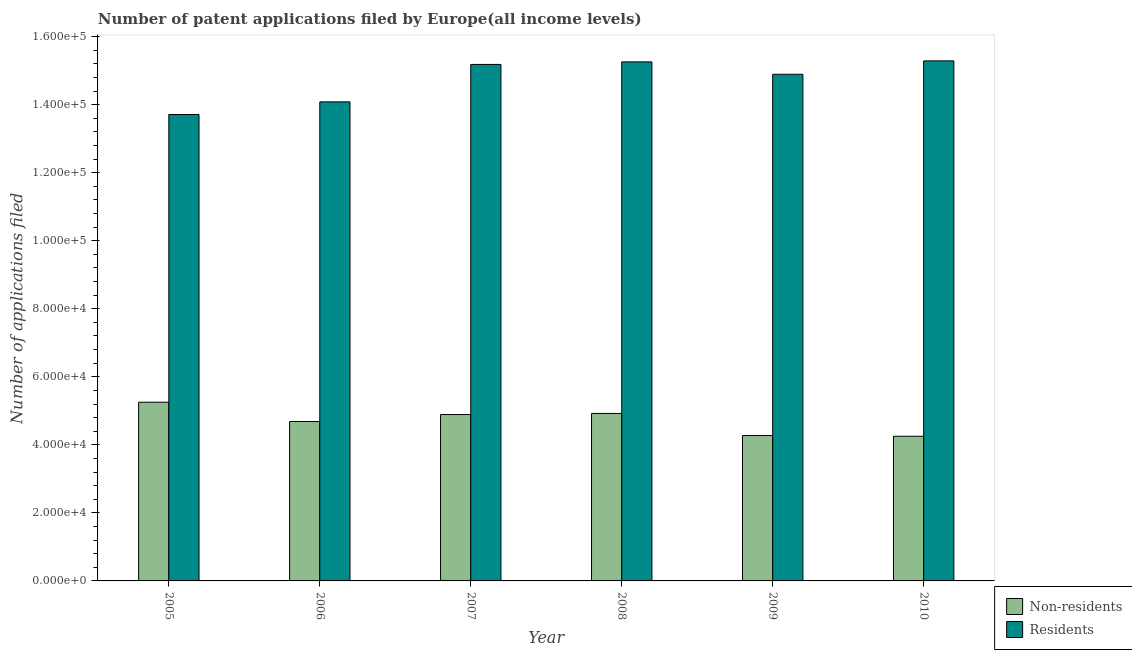How many different coloured bars are there?
Your response must be concise. 2. How many bars are there on the 3rd tick from the right?
Offer a very short reply. 2. What is the number of patent applications by residents in 2008?
Offer a very short reply. 1.53e+05. Across all years, what is the maximum number of patent applications by residents?
Provide a succinct answer. 1.53e+05. Across all years, what is the minimum number of patent applications by non residents?
Make the answer very short. 4.25e+04. In which year was the number of patent applications by non residents maximum?
Provide a short and direct response. 2005. In which year was the number of patent applications by residents minimum?
Your answer should be compact. 2005. What is the total number of patent applications by non residents in the graph?
Ensure brevity in your answer.  2.83e+05. What is the difference between the number of patent applications by residents in 2006 and that in 2009?
Your response must be concise. -8110. What is the difference between the number of patent applications by residents in 2006 and the number of patent applications by non residents in 2009?
Your answer should be very brief. -8110. What is the average number of patent applications by non residents per year?
Provide a succinct answer. 4.71e+04. In how many years, is the number of patent applications by non residents greater than 116000?
Offer a terse response. 0. What is the ratio of the number of patent applications by non residents in 2006 to that in 2007?
Provide a short and direct response. 0.96. Is the difference between the number of patent applications by residents in 2007 and 2008 greater than the difference between the number of patent applications by non residents in 2007 and 2008?
Provide a succinct answer. No. What is the difference between the highest and the second highest number of patent applications by non residents?
Provide a short and direct response. 3296. What is the difference between the highest and the lowest number of patent applications by residents?
Provide a short and direct response. 1.58e+04. In how many years, is the number of patent applications by residents greater than the average number of patent applications by residents taken over all years?
Offer a terse response. 4. Is the sum of the number of patent applications by residents in 2007 and 2009 greater than the maximum number of patent applications by non residents across all years?
Keep it short and to the point. Yes. What does the 2nd bar from the left in 2006 represents?
Your answer should be compact. Residents. What does the 1st bar from the right in 2009 represents?
Ensure brevity in your answer.  Residents. How many years are there in the graph?
Provide a succinct answer. 6. What is the difference between two consecutive major ticks on the Y-axis?
Your response must be concise. 2.00e+04. Are the values on the major ticks of Y-axis written in scientific E-notation?
Provide a succinct answer. Yes. Does the graph contain any zero values?
Your answer should be very brief. No. How are the legend labels stacked?
Your response must be concise. Vertical. What is the title of the graph?
Your answer should be very brief. Number of patent applications filed by Europe(all income levels). What is the label or title of the X-axis?
Make the answer very short. Year. What is the label or title of the Y-axis?
Offer a very short reply. Number of applications filed. What is the Number of applications filed in Non-residents in 2005?
Ensure brevity in your answer.  5.25e+04. What is the Number of applications filed in Residents in 2005?
Keep it short and to the point. 1.37e+05. What is the Number of applications filed of Non-residents in 2006?
Provide a succinct answer. 4.69e+04. What is the Number of applications filed of Residents in 2006?
Offer a very short reply. 1.41e+05. What is the Number of applications filed in Non-residents in 2007?
Your response must be concise. 4.89e+04. What is the Number of applications filed in Residents in 2007?
Provide a short and direct response. 1.52e+05. What is the Number of applications filed in Non-residents in 2008?
Your answer should be very brief. 4.92e+04. What is the Number of applications filed of Residents in 2008?
Provide a succinct answer. 1.53e+05. What is the Number of applications filed of Non-residents in 2009?
Offer a terse response. 4.27e+04. What is the Number of applications filed of Residents in 2009?
Ensure brevity in your answer.  1.49e+05. What is the Number of applications filed of Non-residents in 2010?
Offer a terse response. 4.25e+04. What is the Number of applications filed in Residents in 2010?
Make the answer very short. 1.53e+05. Across all years, what is the maximum Number of applications filed in Non-residents?
Your response must be concise. 5.25e+04. Across all years, what is the maximum Number of applications filed in Residents?
Provide a succinct answer. 1.53e+05. Across all years, what is the minimum Number of applications filed of Non-residents?
Your answer should be compact. 4.25e+04. Across all years, what is the minimum Number of applications filed of Residents?
Offer a very short reply. 1.37e+05. What is the total Number of applications filed of Non-residents in the graph?
Your answer should be very brief. 2.83e+05. What is the total Number of applications filed of Residents in the graph?
Provide a short and direct response. 8.84e+05. What is the difference between the Number of applications filed of Non-residents in 2005 and that in 2006?
Ensure brevity in your answer.  5674. What is the difference between the Number of applications filed in Residents in 2005 and that in 2006?
Your answer should be very brief. -3721. What is the difference between the Number of applications filed in Non-residents in 2005 and that in 2007?
Offer a very short reply. 3624. What is the difference between the Number of applications filed in Residents in 2005 and that in 2007?
Your answer should be very brief. -1.47e+04. What is the difference between the Number of applications filed in Non-residents in 2005 and that in 2008?
Provide a succinct answer. 3296. What is the difference between the Number of applications filed of Residents in 2005 and that in 2008?
Give a very brief answer. -1.55e+04. What is the difference between the Number of applications filed of Non-residents in 2005 and that in 2009?
Your answer should be very brief. 9797. What is the difference between the Number of applications filed of Residents in 2005 and that in 2009?
Offer a very short reply. -1.18e+04. What is the difference between the Number of applications filed of Non-residents in 2005 and that in 2010?
Provide a succinct answer. 1.00e+04. What is the difference between the Number of applications filed of Residents in 2005 and that in 2010?
Give a very brief answer. -1.58e+04. What is the difference between the Number of applications filed in Non-residents in 2006 and that in 2007?
Give a very brief answer. -2050. What is the difference between the Number of applications filed in Residents in 2006 and that in 2007?
Provide a succinct answer. -1.10e+04. What is the difference between the Number of applications filed of Non-residents in 2006 and that in 2008?
Make the answer very short. -2378. What is the difference between the Number of applications filed in Residents in 2006 and that in 2008?
Provide a short and direct response. -1.18e+04. What is the difference between the Number of applications filed in Non-residents in 2006 and that in 2009?
Offer a terse response. 4123. What is the difference between the Number of applications filed of Residents in 2006 and that in 2009?
Make the answer very short. -8110. What is the difference between the Number of applications filed in Non-residents in 2006 and that in 2010?
Provide a succinct answer. 4332. What is the difference between the Number of applications filed in Residents in 2006 and that in 2010?
Ensure brevity in your answer.  -1.20e+04. What is the difference between the Number of applications filed in Non-residents in 2007 and that in 2008?
Your answer should be very brief. -328. What is the difference between the Number of applications filed in Residents in 2007 and that in 2008?
Offer a terse response. -745. What is the difference between the Number of applications filed of Non-residents in 2007 and that in 2009?
Offer a terse response. 6173. What is the difference between the Number of applications filed of Residents in 2007 and that in 2009?
Keep it short and to the point. 2895. What is the difference between the Number of applications filed of Non-residents in 2007 and that in 2010?
Ensure brevity in your answer.  6382. What is the difference between the Number of applications filed in Residents in 2007 and that in 2010?
Your answer should be very brief. -1043. What is the difference between the Number of applications filed of Non-residents in 2008 and that in 2009?
Provide a short and direct response. 6501. What is the difference between the Number of applications filed of Residents in 2008 and that in 2009?
Your response must be concise. 3640. What is the difference between the Number of applications filed of Non-residents in 2008 and that in 2010?
Give a very brief answer. 6710. What is the difference between the Number of applications filed of Residents in 2008 and that in 2010?
Offer a terse response. -298. What is the difference between the Number of applications filed of Non-residents in 2009 and that in 2010?
Offer a terse response. 209. What is the difference between the Number of applications filed in Residents in 2009 and that in 2010?
Ensure brevity in your answer.  -3938. What is the difference between the Number of applications filed in Non-residents in 2005 and the Number of applications filed in Residents in 2006?
Offer a terse response. -8.83e+04. What is the difference between the Number of applications filed in Non-residents in 2005 and the Number of applications filed in Residents in 2007?
Give a very brief answer. -9.93e+04. What is the difference between the Number of applications filed of Non-residents in 2005 and the Number of applications filed of Residents in 2008?
Provide a short and direct response. -1.00e+05. What is the difference between the Number of applications filed of Non-residents in 2005 and the Number of applications filed of Residents in 2009?
Offer a very short reply. -9.64e+04. What is the difference between the Number of applications filed of Non-residents in 2005 and the Number of applications filed of Residents in 2010?
Provide a short and direct response. -1.00e+05. What is the difference between the Number of applications filed in Non-residents in 2006 and the Number of applications filed in Residents in 2007?
Give a very brief answer. -1.05e+05. What is the difference between the Number of applications filed of Non-residents in 2006 and the Number of applications filed of Residents in 2008?
Offer a very short reply. -1.06e+05. What is the difference between the Number of applications filed in Non-residents in 2006 and the Number of applications filed in Residents in 2009?
Provide a succinct answer. -1.02e+05. What is the difference between the Number of applications filed in Non-residents in 2006 and the Number of applications filed in Residents in 2010?
Make the answer very short. -1.06e+05. What is the difference between the Number of applications filed of Non-residents in 2007 and the Number of applications filed of Residents in 2008?
Offer a very short reply. -1.04e+05. What is the difference between the Number of applications filed in Non-residents in 2007 and the Number of applications filed in Residents in 2009?
Your answer should be very brief. -1.00e+05. What is the difference between the Number of applications filed of Non-residents in 2007 and the Number of applications filed of Residents in 2010?
Keep it short and to the point. -1.04e+05. What is the difference between the Number of applications filed of Non-residents in 2008 and the Number of applications filed of Residents in 2009?
Your answer should be compact. -9.97e+04. What is the difference between the Number of applications filed in Non-residents in 2008 and the Number of applications filed in Residents in 2010?
Your answer should be very brief. -1.04e+05. What is the difference between the Number of applications filed of Non-residents in 2009 and the Number of applications filed of Residents in 2010?
Your answer should be very brief. -1.10e+05. What is the average Number of applications filed of Non-residents per year?
Make the answer very short. 4.71e+04. What is the average Number of applications filed of Residents per year?
Your answer should be very brief. 1.47e+05. In the year 2005, what is the difference between the Number of applications filed of Non-residents and Number of applications filed of Residents?
Your response must be concise. -8.46e+04. In the year 2006, what is the difference between the Number of applications filed in Non-residents and Number of applications filed in Residents?
Your answer should be compact. -9.40e+04. In the year 2007, what is the difference between the Number of applications filed of Non-residents and Number of applications filed of Residents?
Your answer should be very brief. -1.03e+05. In the year 2008, what is the difference between the Number of applications filed of Non-residents and Number of applications filed of Residents?
Provide a short and direct response. -1.03e+05. In the year 2009, what is the difference between the Number of applications filed of Non-residents and Number of applications filed of Residents?
Offer a terse response. -1.06e+05. In the year 2010, what is the difference between the Number of applications filed of Non-residents and Number of applications filed of Residents?
Your answer should be very brief. -1.10e+05. What is the ratio of the Number of applications filed of Non-residents in 2005 to that in 2006?
Provide a succinct answer. 1.12. What is the ratio of the Number of applications filed of Residents in 2005 to that in 2006?
Provide a succinct answer. 0.97. What is the ratio of the Number of applications filed in Non-residents in 2005 to that in 2007?
Your answer should be very brief. 1.07. What is the ratio of the Number of applications filed of Residents in 2005 to that in 2007?
Your response must be concise. 0.9. What is the ratio of the Number of applications filed of Non-residents in 2005 to that in 2008?
Your answer should be very brief. 1.07. What is the ratio of the Number of applications filed in Residents in 2005 to that in 2008?
Offer a very short reply. 0.9. What is the ratio of the Number of applications filed of Non-residents in 2005 to that in 2009?
Provide a succinct answer. 1.23. What is the ratio of the Number of applications filed of Residents in 2005 to that in 2009?
Provide a succinct answer. 0.92. What is the ratio of the Number of applications filed of Non-residents in 2005 to that in 2010?
Ensure brevity in your answer.  1.24. What is the ratio of the Number of applications filed of Residents in 2005 to that in 2010?
Provide a succinct answer. 0.9. What is the ratio of the Number of applications filed in Non-residents in 2006 to that in 2007?
Your answer should be compact. 0.96. What is the ratio of the Number of applications filed in Residents in 2006 to that in 2007?
Provide a short and direct response. 0.93. What is the ratio of the Number of applications filed in Non-residents in 2006 to that in 2008?
Your response must be concise. 0.95. What is the ratio of the Number of applications filed of Residents in 2006 to that in 2008?
Give a very brief answer. 0.92. What is the ratio of the Number of applications filed of Non-residents in 2006 to that in 2009?
Your answer should be very brief. 1.1. What is the ratio of the Number of applications filed of Residents in 2006 to that in 2009?
Your answer should be compact. 0.95. What is the ratio of the Number of applications filed of Non-residents in 2006 to that in 2010?
Offer a very short reply. 1.1. What is the ratio of the Number of applications filed of Residents in 2006 to that in 2010?
Keep it short and to the point. 0.92. What is the ratio of the Number of applications filed in Non-residents in 2007 to that in 2008?
Keep it short and to the point. 0.99. What is the ratio of the Number of applications filed of Residents in 2007 to that in 2008?
Offer a very short reply. 1. What is the ratio of the Number of applications filed of Non-residents in 2007 to that in 2009?
Provide a succinct answer. 1.14. What is the ratio of the Number of applications filed of Residents in 2007 to that in 2009?
Your answer should be compact. 1.02. What is the ratio of the Number of applications filed of Non-residents in 2007 to that in 2010?
Make the answer very short. 1.15. What is the ratio of the Number of applications filed of Residents in 2007 to that in 2010?
Your answer should be very brief. 0.99. What is the ratio of the Number of applications filed in Non-residents in 2008 to that in 2009?
Provide a succinct answer. 1.15. What is the ratio of the Number of applications filed in Residents in 2008 to that in 2009?
Offer a very short reply. 1.02. What is the ratio of the Number of applications filed of Non-residents in 2008 to that in 2010?
Offer a terse response. 1.16. What is the ratio of the Number of applications filed in Non-residents in 2009 to that in 2010?
Provide a short and direct response. 1. What is the ratio of the Number of applications filed in Residents in 2009 to that in 2010?
Your answer should be very brief. 0.97. What is the difference between the highest and the second highest Number of applications filed of Non-residents?
Keep it short and to the point. 3296. What is the difference between the highest and the second highest Number of applications filed in Residents?
Your response must be concise. 298. What is the difference between the highest and the lowest Number of applications filed in Non-residents?
Offer a terse response. 1.00e+04. What is the difference between the highest and the lowest Number of applications filed of Residents?
Ensure brevity in your answer.  1.58e+04. 